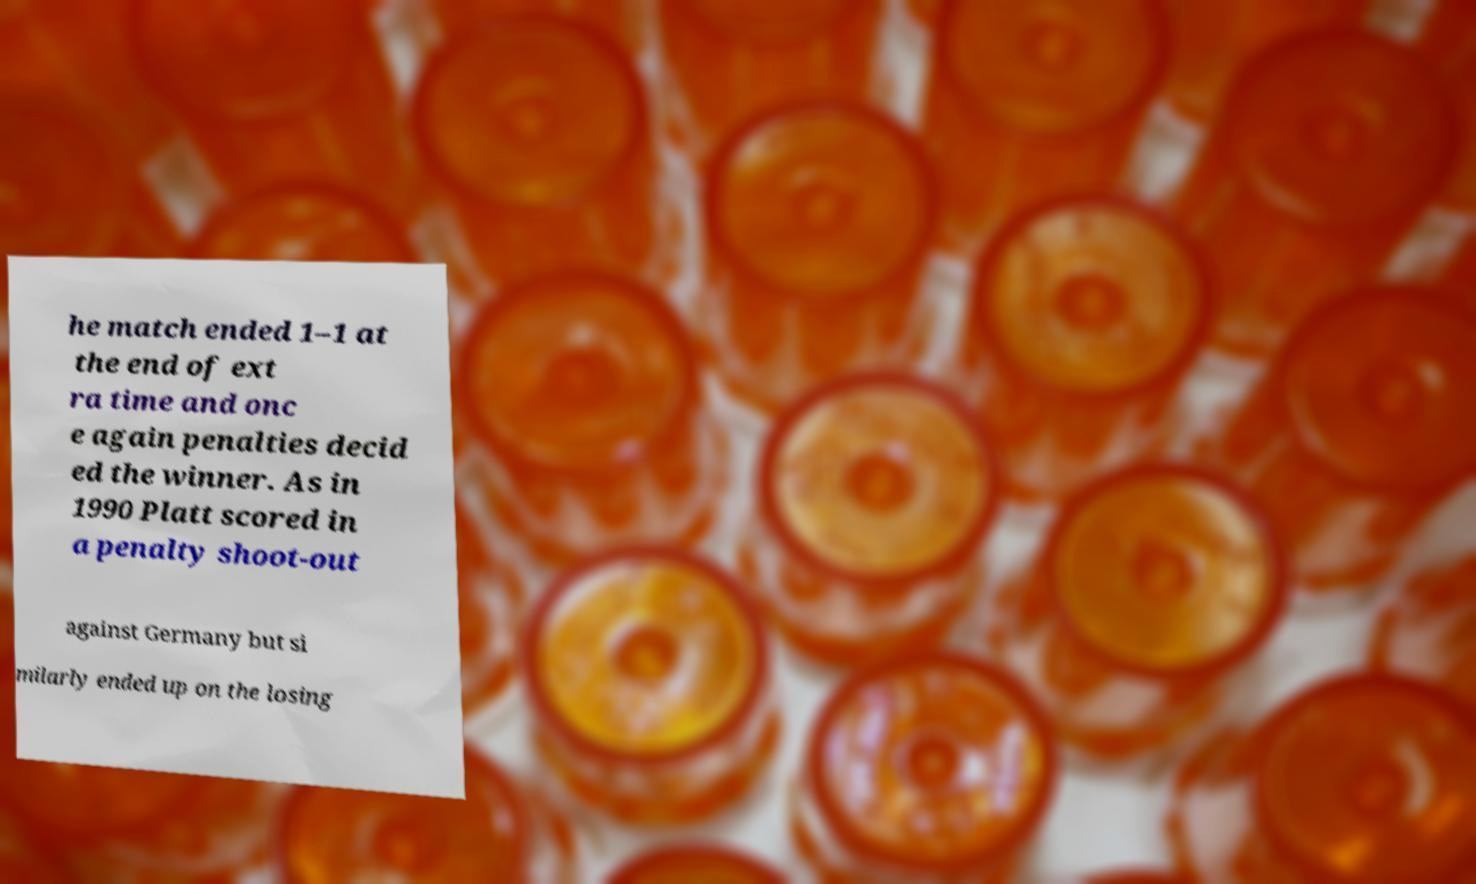What messages or text are displayed in this image? I need them in a readable, typed format. he match ended 1–1 at the end of ext ra time and onc e again penalties decid ed the winner. As in 1990 Platt scored in a penalty shoot-out against Germany but si milarly ended up on the losing 